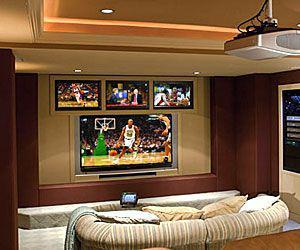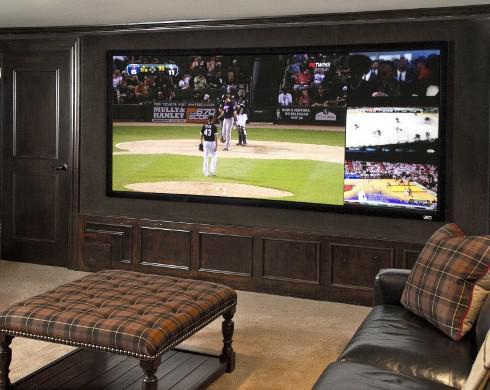The first image is the image on the left, the second image is the image on the right. Evaluate the accuracy of this statement regarding the images: "None of the screens show a basketball game.". Is it true? Answer yes or no. No. The first image is the image on the left, the second image is the image on the right. Assess this claim about the two images: "there are lights haging over the bar". Correct or not? Answer yes or no. No. 